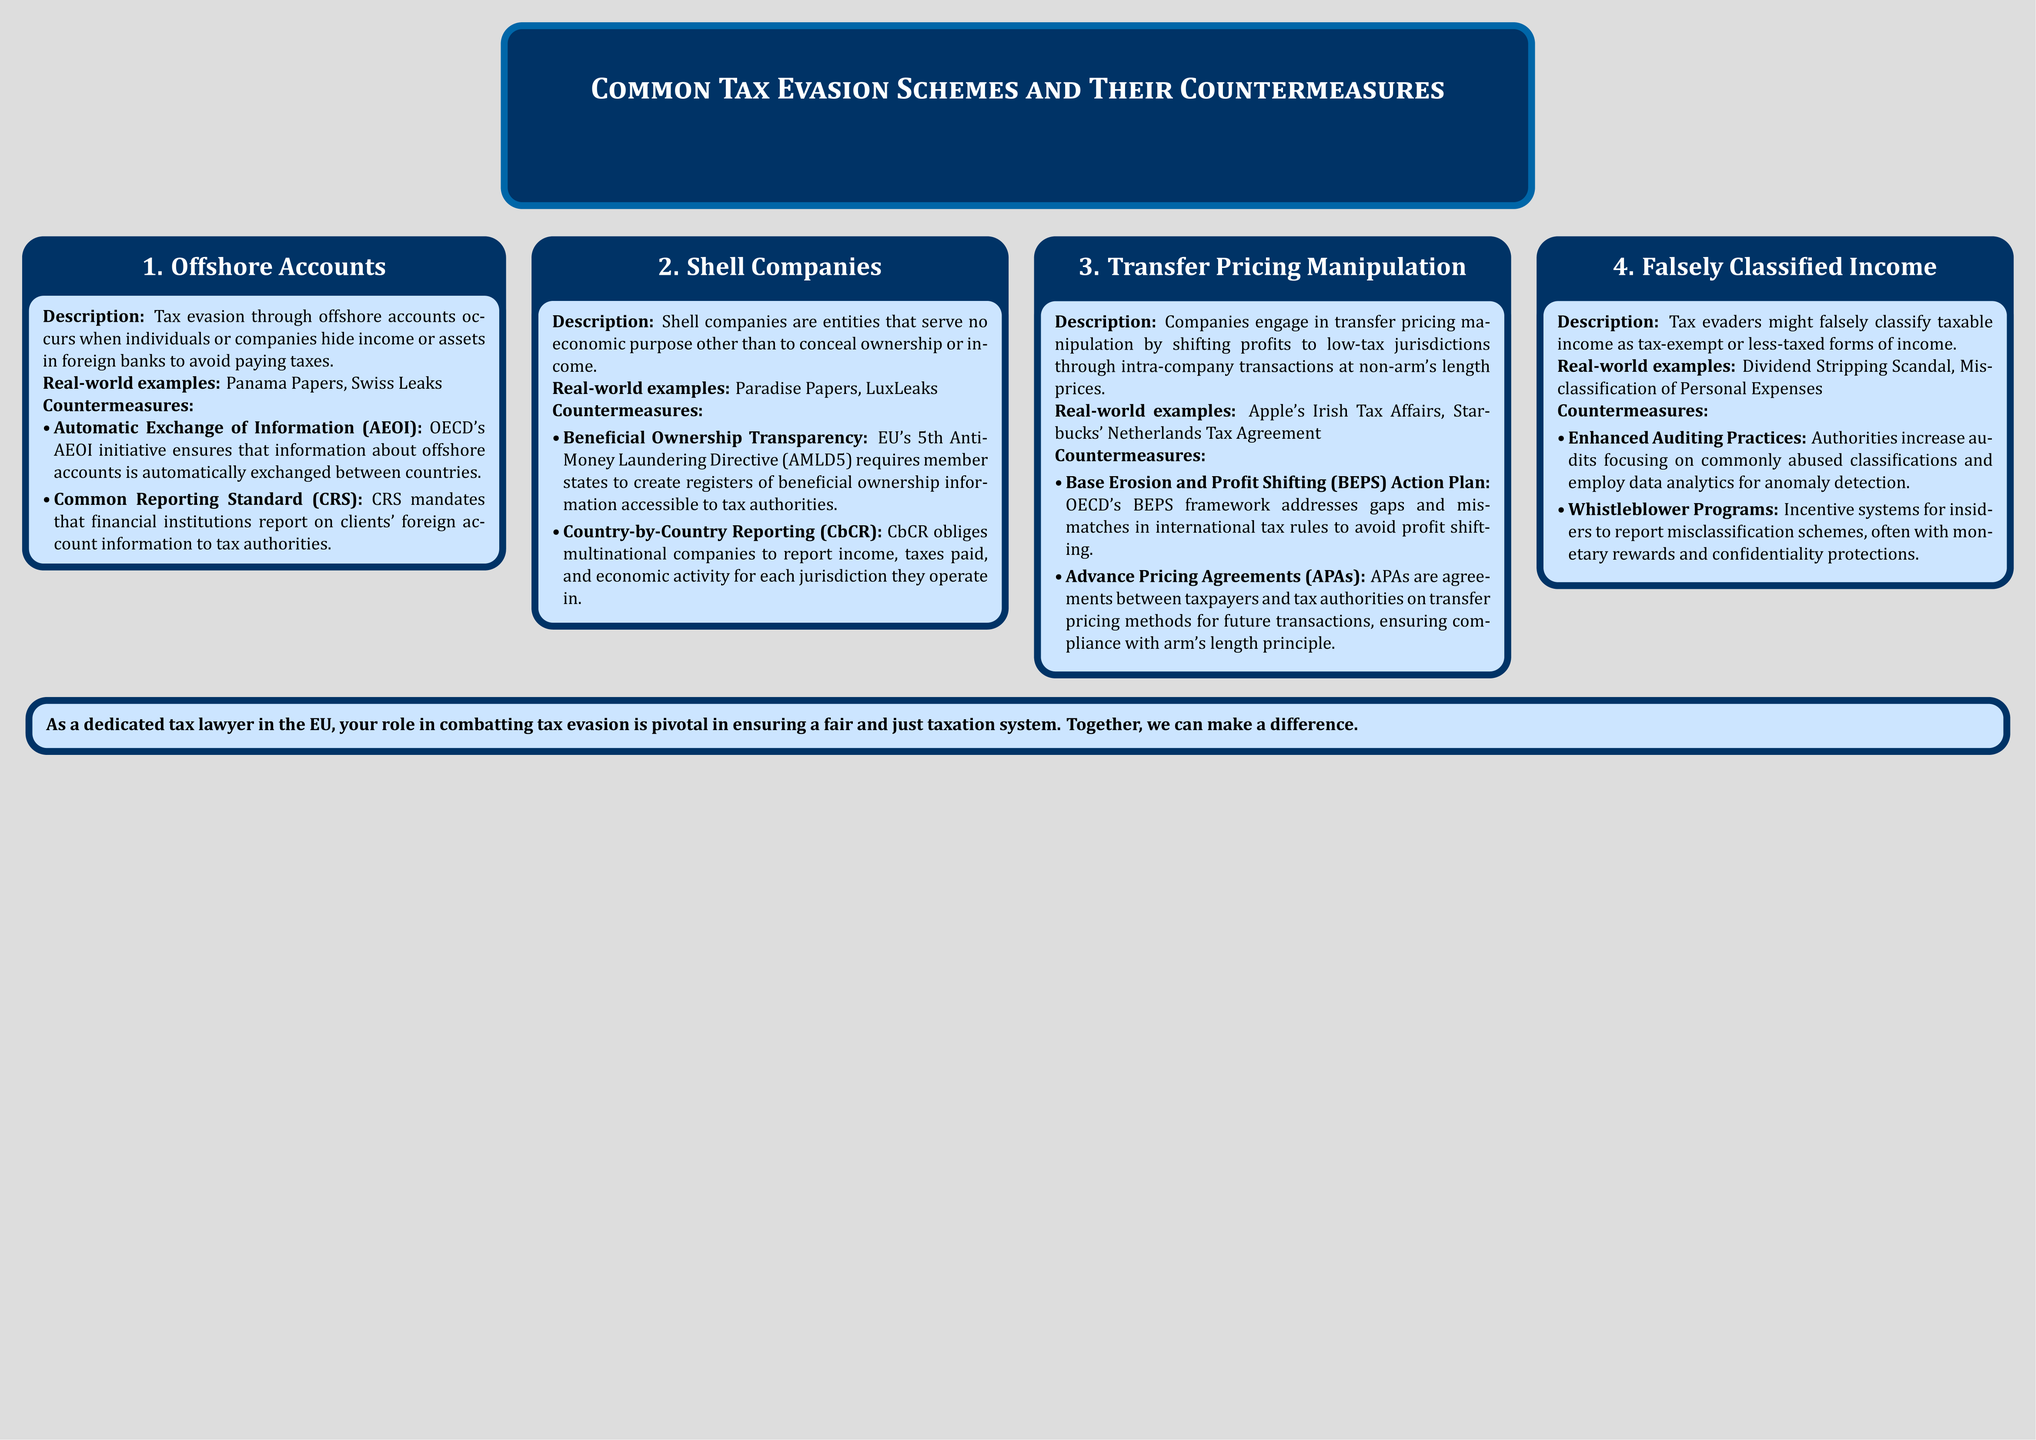What are offshore accounts used for? Offshore accounts are used to hide income or assets in foreign banks to avoid paying taxes.
Answer: Hiding income or assets What does AEOI stand for? AEOI stands for Automatic Exchange of Information, a countermeasure for offshore accounts.
Answer: Automatic Exchange of Information Which directive requires beneficial ownership transparency? The 5th Anti-Money Laundering Directive (AMLD5) requires beneficial ownership transparency.
Answer: 5th Anti-Money Laundering Directive What is a real-world example of transfer pricing manipulation? Apple's Irish Tax Affairs is a real-world example of transfer pricing manipulation.
Answer: Apple's Irish Tax Affairs What is one countermeasure to falsely classified income? Enhanced Auditing Practices is one countermeasure to falsely classified income.
Answer: Enhanced Auditing Practices How many common tax evasion schemes are listed in the document? The document lists four common tax evasion schemes.
Answer: Four What does CbCR stand for? CbCR stands for Country-by-Country Reporting, which is a countermeasure against shell companies.
Answer: Country-by-Country Reporting What is a purpose of Advance Pricing Agreements (APAs)? APAs are agreements on transfer pricing methods for future transactions.
Answer: Agreements on transfer pricing methods Which scandal involved misclassification of income? The Dividend Stripping Scandal involved misclassification of income.
Answer: Dividend Stripping Scandal 